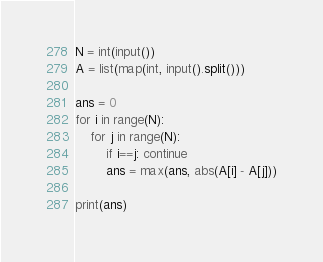<code> <loc_0><loc_0><loc_500><loc_500><_Python_>N = int(input())
A = list(map(int, input().split()))

ans = 0
for i in range(N):
    for j in range(N):
        if i==j: continue
        ans = max(ans, abs(A[i] - A[j]))

print(ans)</code> 